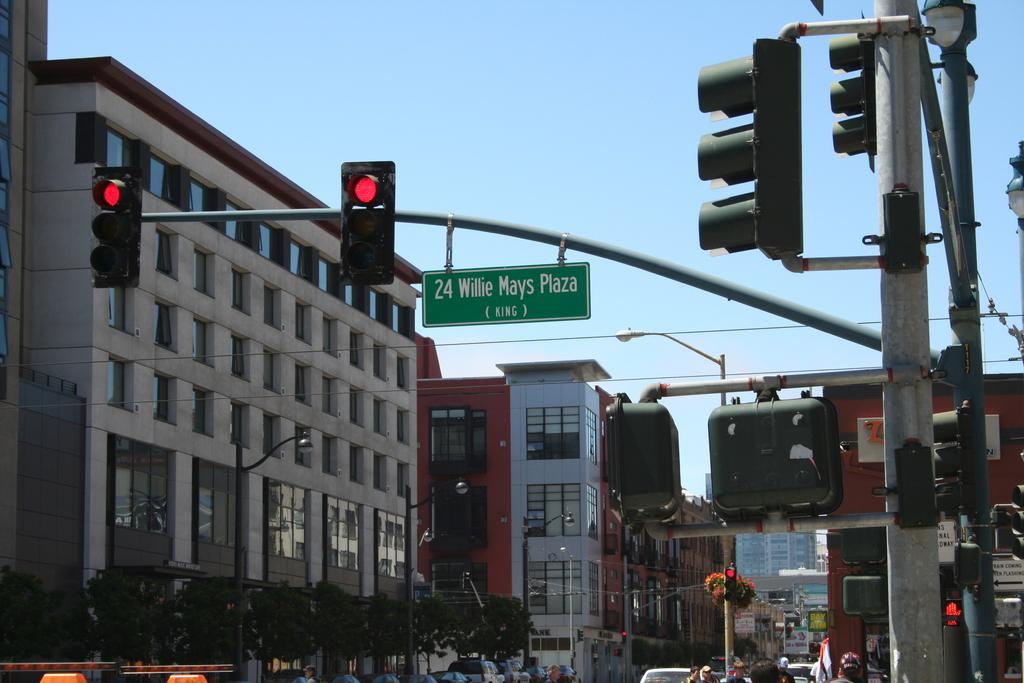<image>
Present a compact description of the photo's key features. 24 willie mays plaze street sign on a busy street 